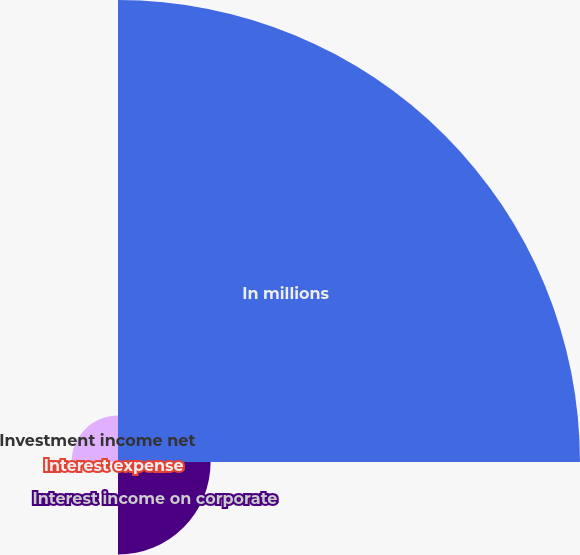<chart> <loc_0><loc_0><loc_500><loc_500><pie_chart><fcel>In millions<fcel>Interest income on corporate<fcel>Interest expense<fcel>Investment income net<nl><fcel>76.84%<fcel>15.4%<fcel>0.04%<fcel>7.72%<nl></chart> 